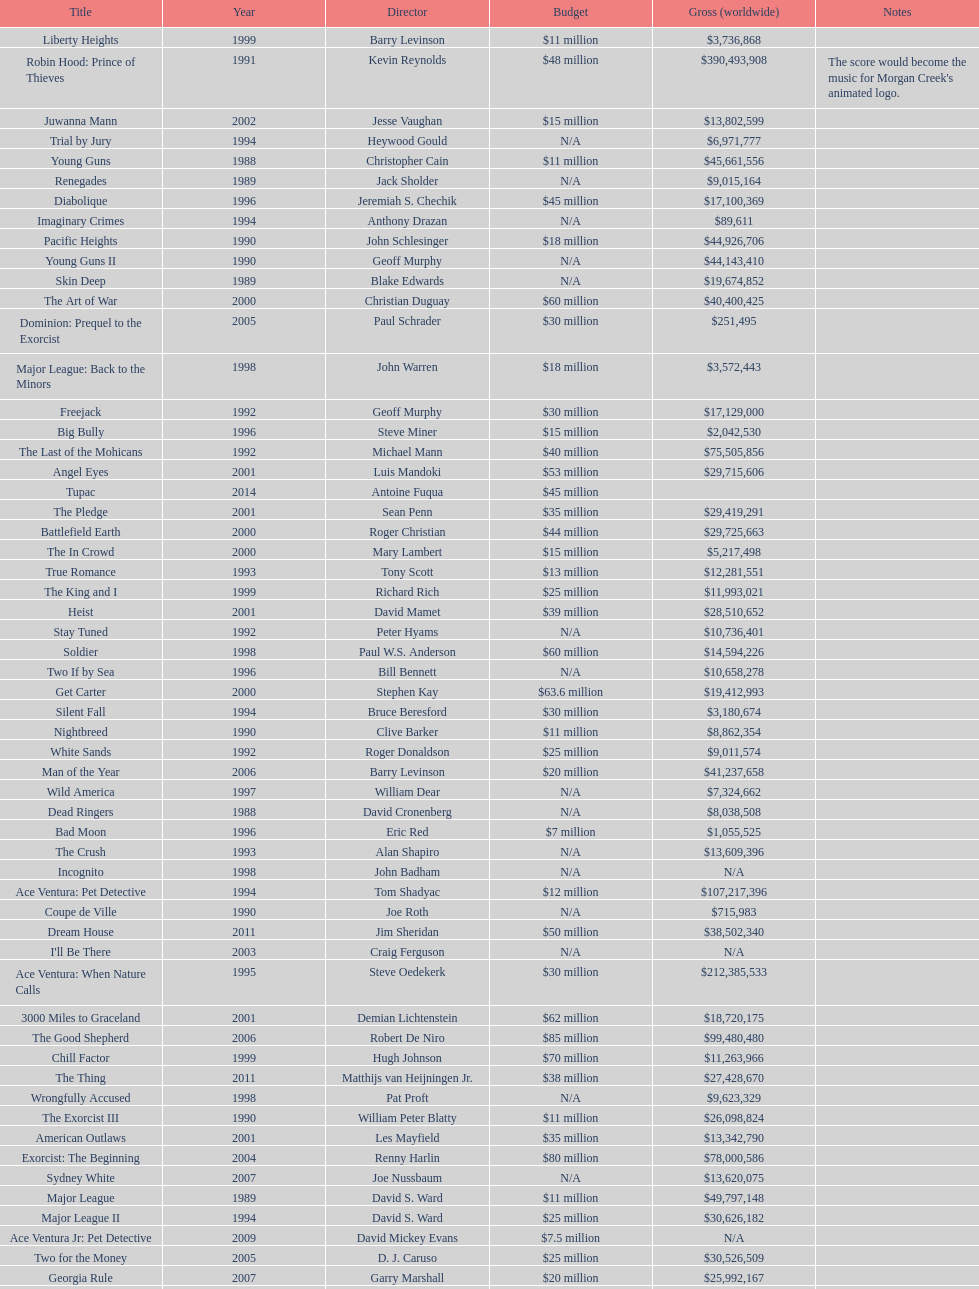What movie was made immediately before the pledge? The In Crowd. 